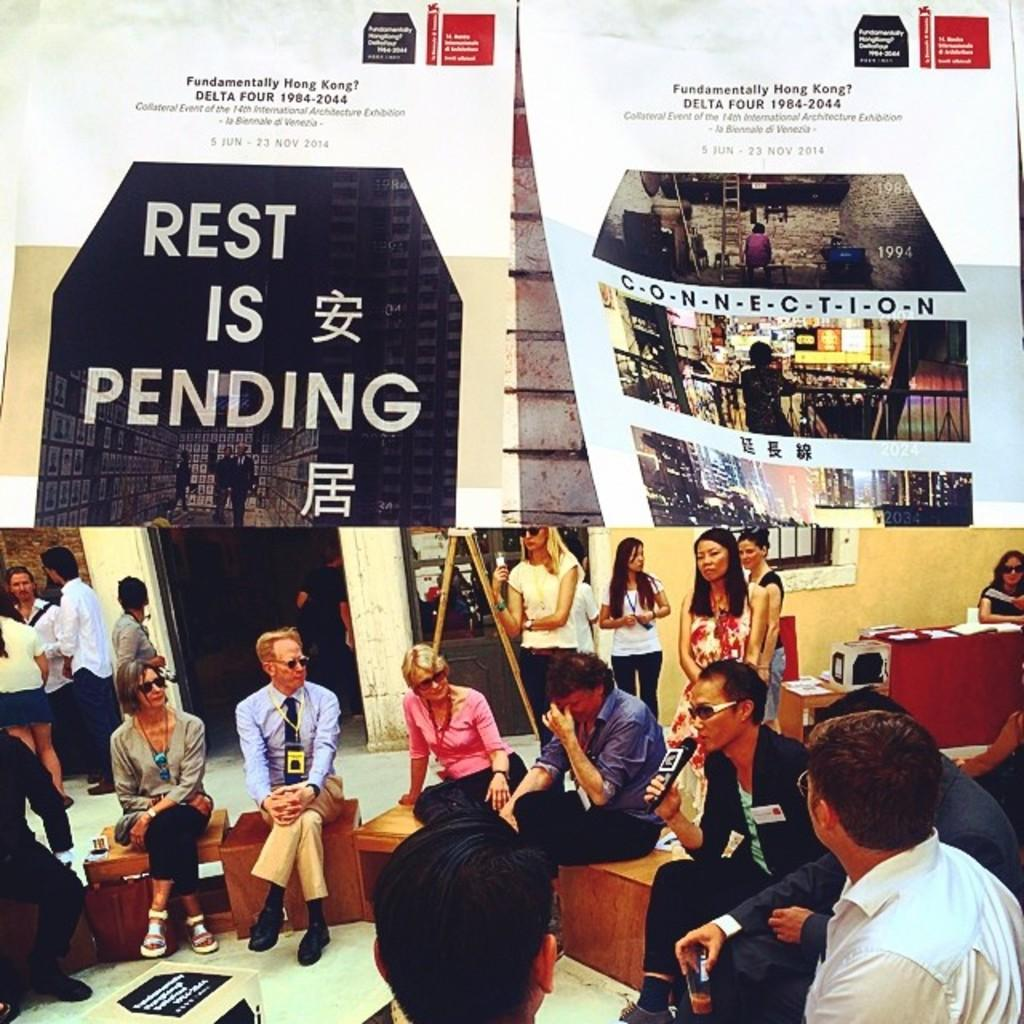What are the people in the image doing? There are people sitting on stools and standing in the image. What else can be seen in the image besides the people? There is a banner visible in the image. How many clams are being served on the plates in the image? There are no plates or clams present in the image; it features people sitting on stools and standing with a banner visible. 